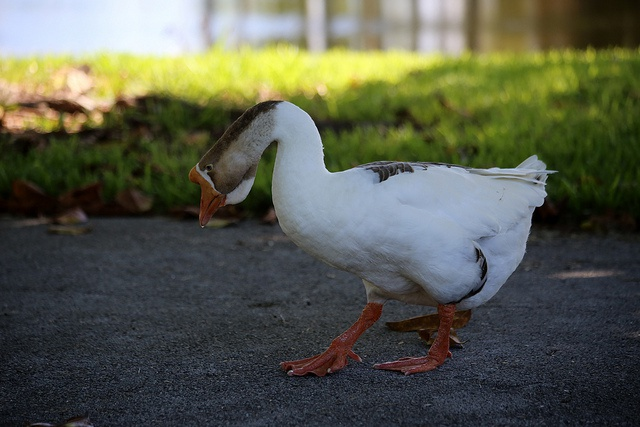Describe the objects in this image and their specific colors. I can see a bird in lavender, darkgray, gray, and black tones in this image. 